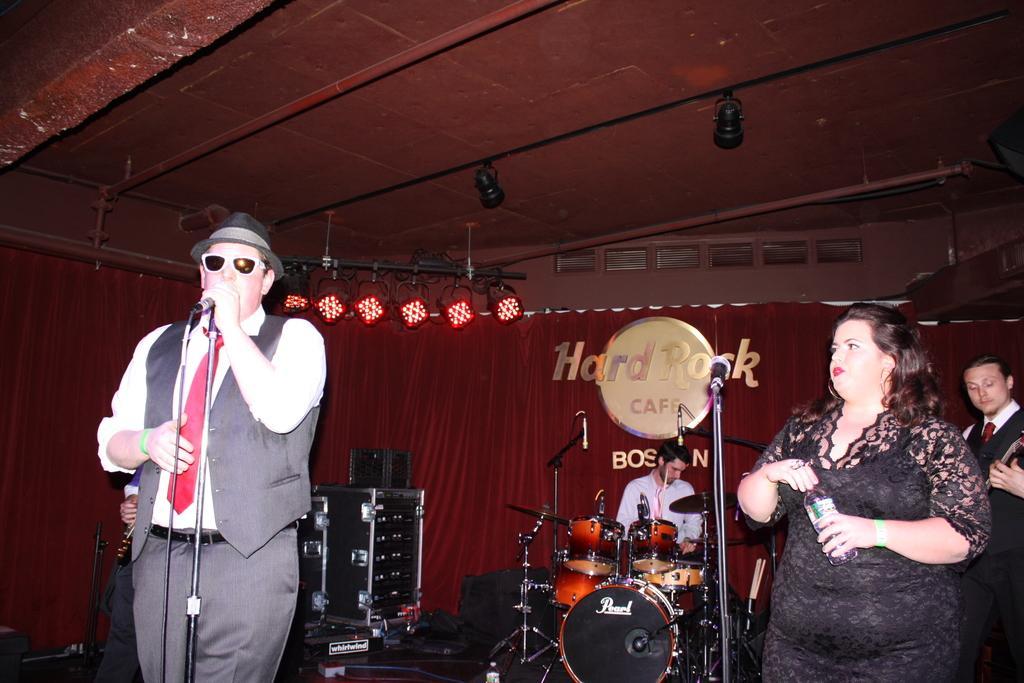Can you describe this image briefly? This is a concert. In this image there are group of persons at the right side of the image there is a woman standing and holding a water bottle in her hand and at the left side of the image standing wearing black color hat and spectacles holding a microphone in his hand and at the background of the image there is a person who is playing a musical instrument and there are also lights at the top of the image and at the background of the image there is a red color curtain on which is written as hard rock cafe. 